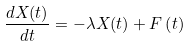<formula> <loc_0><loc_0><loc_500><loc_500>\frac { d X ( t ) } { d t } = - \lambda X ( t ) + F \left ( t \right )</formula> 